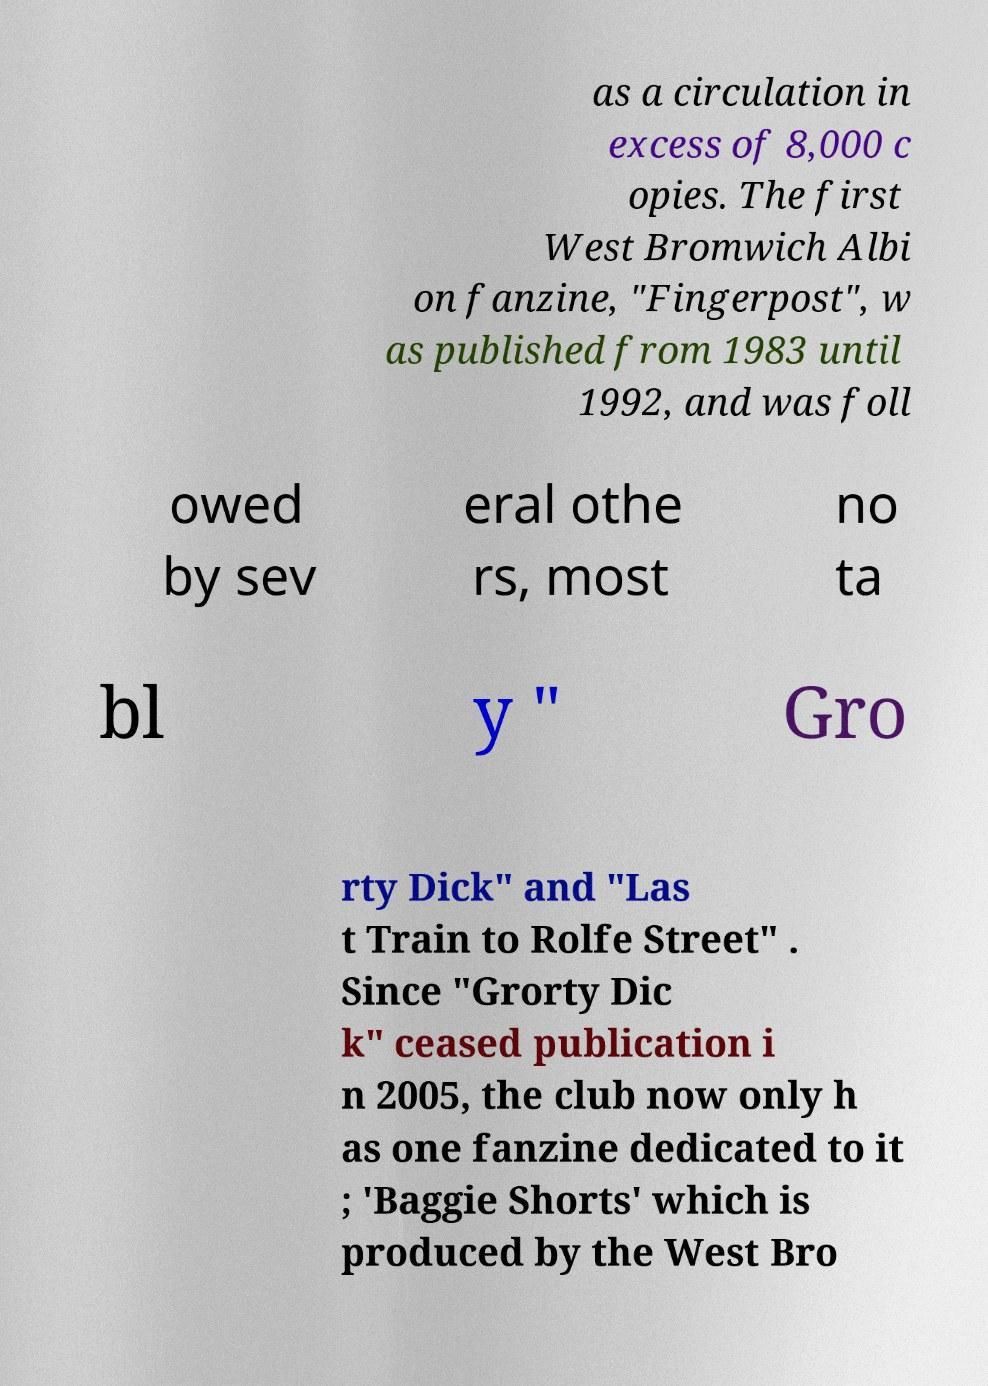What messages or text are displayed in this image? I need them in a readable, typed format. as a circulation in excess of 8,000 c opies. The first West Bromwich Albi on fanzine, "Fingerpost", w as published from 1983 until 1992, and was foll owed by sev eral othe rs, most no ta bl y " Gro rty Dick" and "Las t Train to Rolfe Street" . Since "Grorty Dic k" ceased publication i n 2005, the club now only h as one fanzine dedicated to it ; 'Baggie Shorts' which is produced by the West Bro 